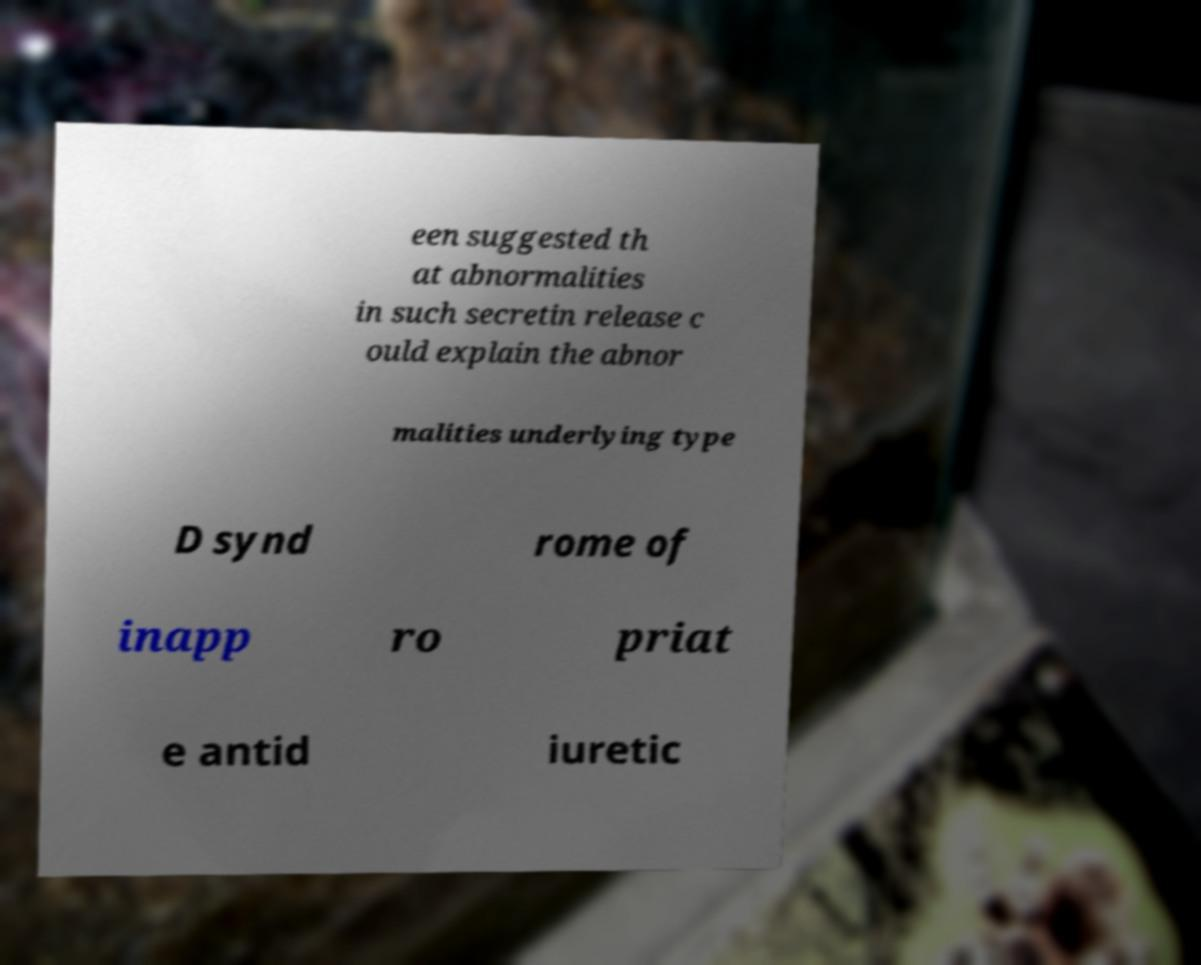What messages or text are displayed in this image? I need them in a readable, typed format. een suggested th at abnormalities in such secretin release c ould explain the abnor malities underlying type D synd rome of inapp ro priat e antid iuretic 